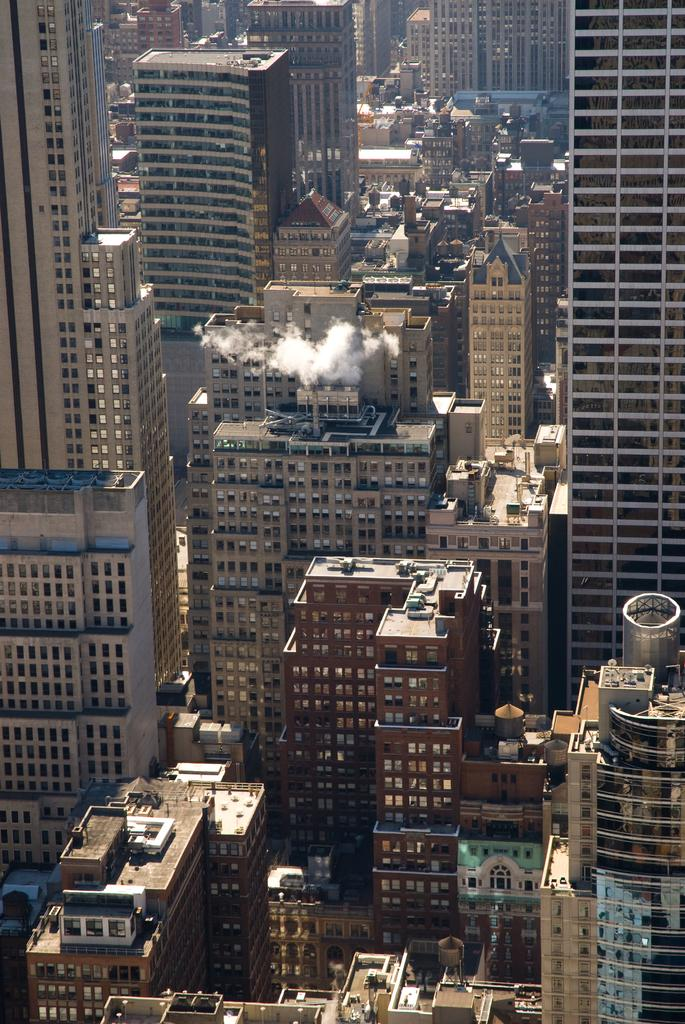What type of structures can be seen in the image? There are many buildings in the image, including tower buildings with multiple floors. What feature do the tower buildings have? The tower buildings have windows. What are the windows made of? The windows have glasses. How does the paper react during the earthquake in the image? There is no paper or earthquake present in the image; it features buildings with windows. What type of wing is attached to the tower buildings in the image? There are no wings attached to the tower buildings in the image; they are regular buildings with windows. 